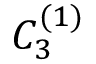<formula> <loc_0><loc_0><loc_500><loc_500>{ C } _ { 3 } ^ { ( 1 ) }</formula> 